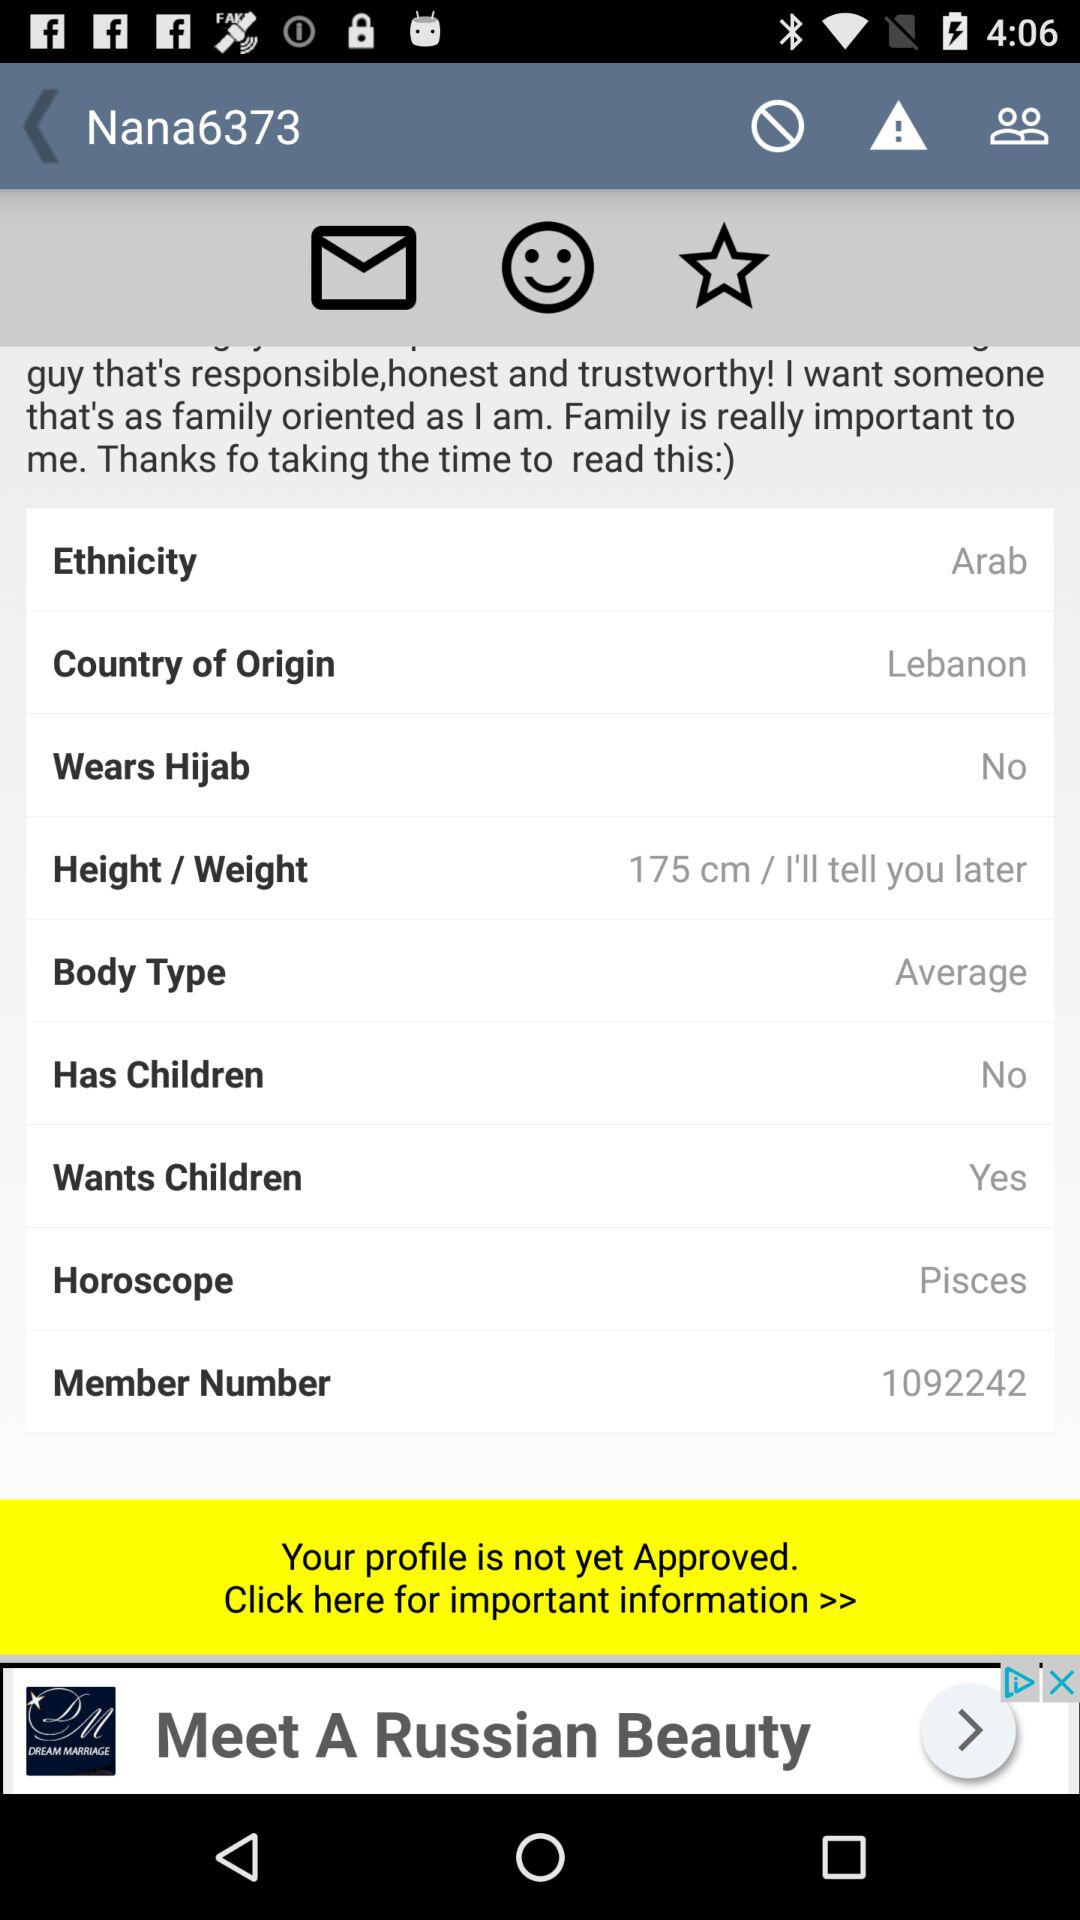What is the country of origin? The country of origin is Lebanon. 